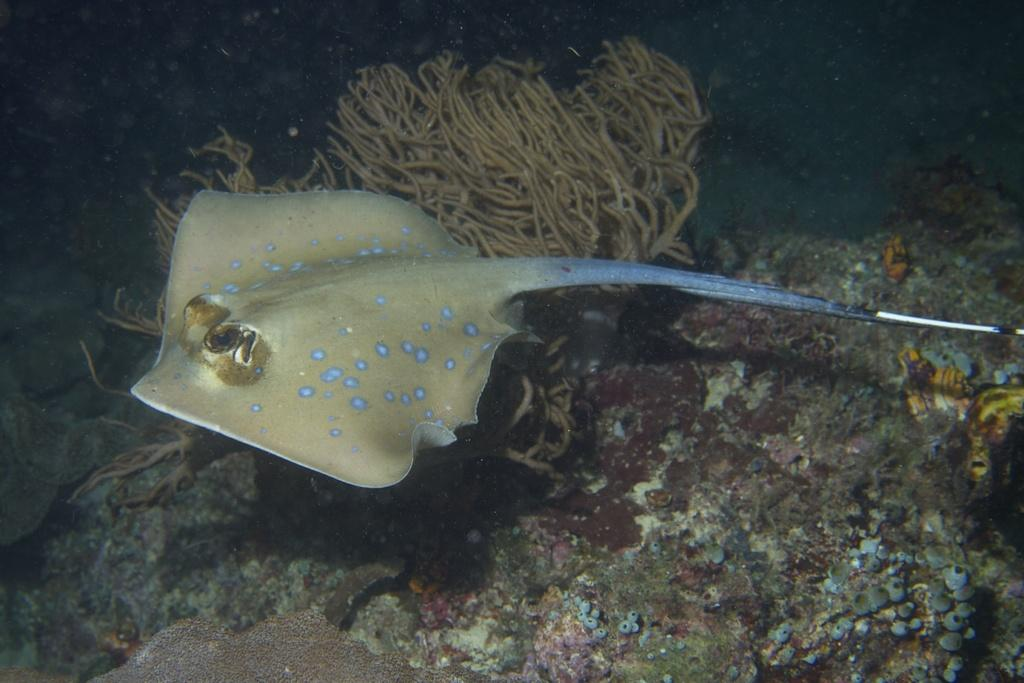What type of animal is in the image? There is a fish in the image. What other marine species can be seen in the image? There are marine species in the image, but the specific types are not mentioned. Where are the marine species located in the image? The marine species are in the water. What type of fan is visible in the image? There is no fan present in the image. What news is being reported in the image? There is no news or any indication of reporting in the image. 